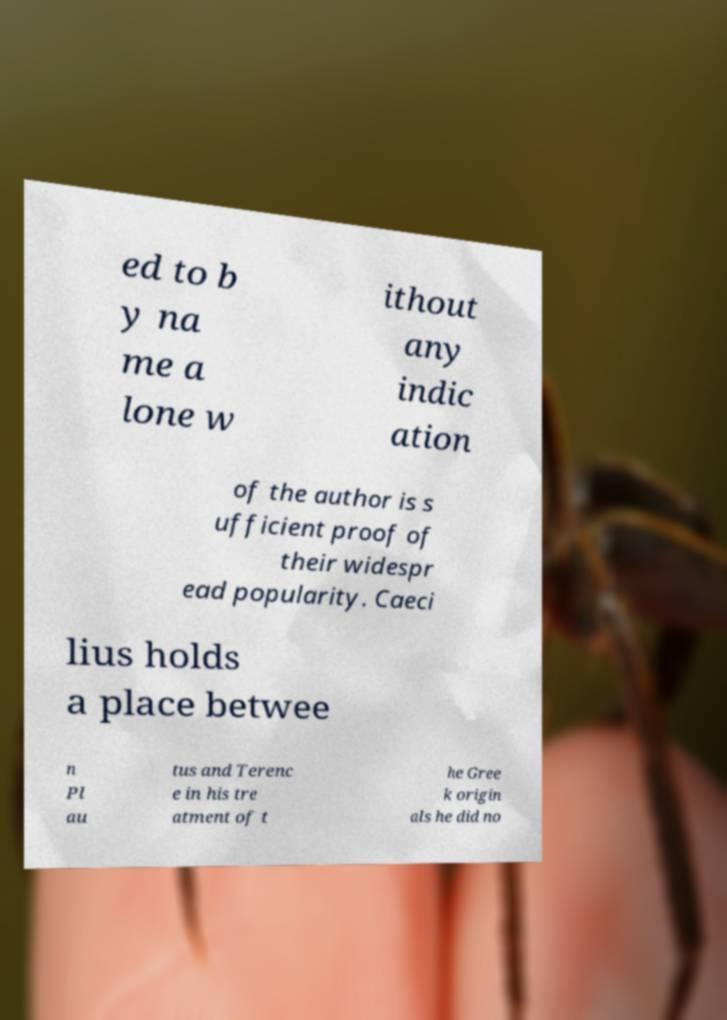Could you extract and type out the text from this image? ed to b y na me a lone w ithout any indic ation of the author is s ufficient proof of their widespr ead popularity. Caeci lius holds a place betwee n Pl au tus and Terenc e in his tre atment of t he Gree k origin als he did no 